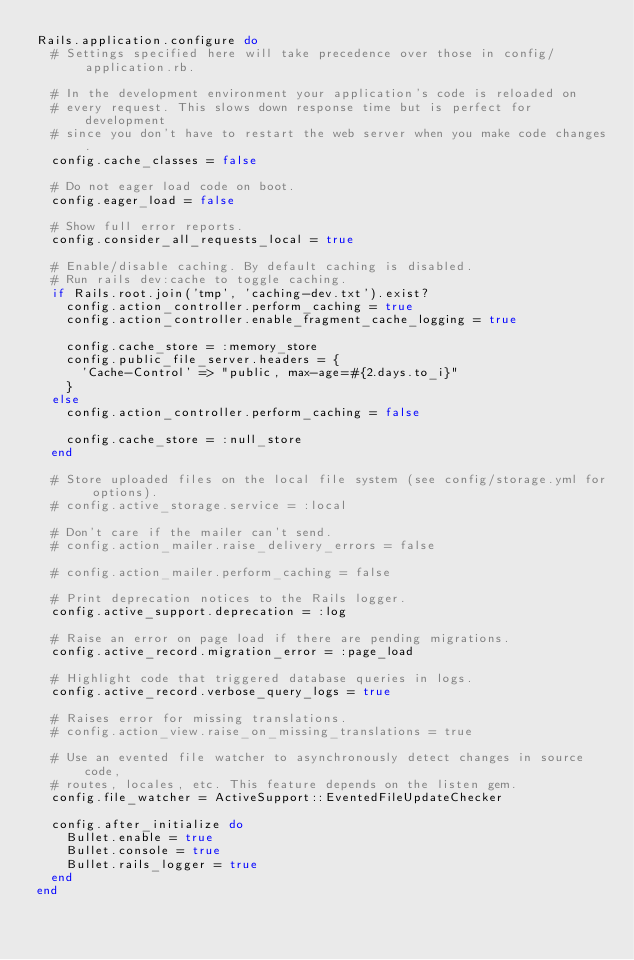<code> <loc_0><loc_0><loc_500><loc_500><_Ruby_>Rails.application.configure do
  # Settings specified here will take precedence over those in config/application.rb.

  # In the development environment your application's code is reloaded on
  # every request. This slows down response time but is perfect for development
  # since you don't have to restart the web server when you make code changes.
  config.cache_classes = false

  # Do not eager load code on boot.
  config.eager_load = false

  # Show full error reports.
  config.consider_all_requests_local = true

  # Enable/disable caching. By default caching is disabled.
  # Run rails dev:cache to toggle caching.
  if Rails.root.join('tmp', 'caching-dev.txt').exist?
    config.action_controller.perform_caching = true
    config.action_controller.enable_fragment_cache_logging = true

    config.cache_store = :memory_store
    config.public_file_server.headers = {
      'Cache-Control' => "public, max-age=#{2.days.to_i}"
    }
  else
    config.action_controller.perform_caching = false

    config.cache_store = :null_store
  end

  # Store uploaded files on the local file system (see config/storage.yml for options).
  # config.active_storage.service = :local

  # Don't care if the mailer can't send.
  # config.action_mailer.raise_delivery_errors = false

  # config.action_mailer.perform_caching = false

  # Print deprecation notices to the Rails logger.
  config.active_support.deprecation = :log

  # Raise an error on page load if there are pending migrations.
  config.active_record.migration_error = :page_load

  # Highlight code that triggered database queries in logs.
  config.active_record.verbose_query_logs = true

  # Raises error for missing translations.
  # config.action_view.raise_on_missing_translations = true

  # Use an evented file watcher to asynchronously detect changes in source code,
  # routes, locales, etc. This feature depends on the listen gem.
  config.file_watcher = ActiveSupport::EventedFileUpdateChecker

  config.after_initialize do
    Bullet.enable = true
    Bullet.console = true
    Bullet.rails_logger = true
  end
end
</code> 